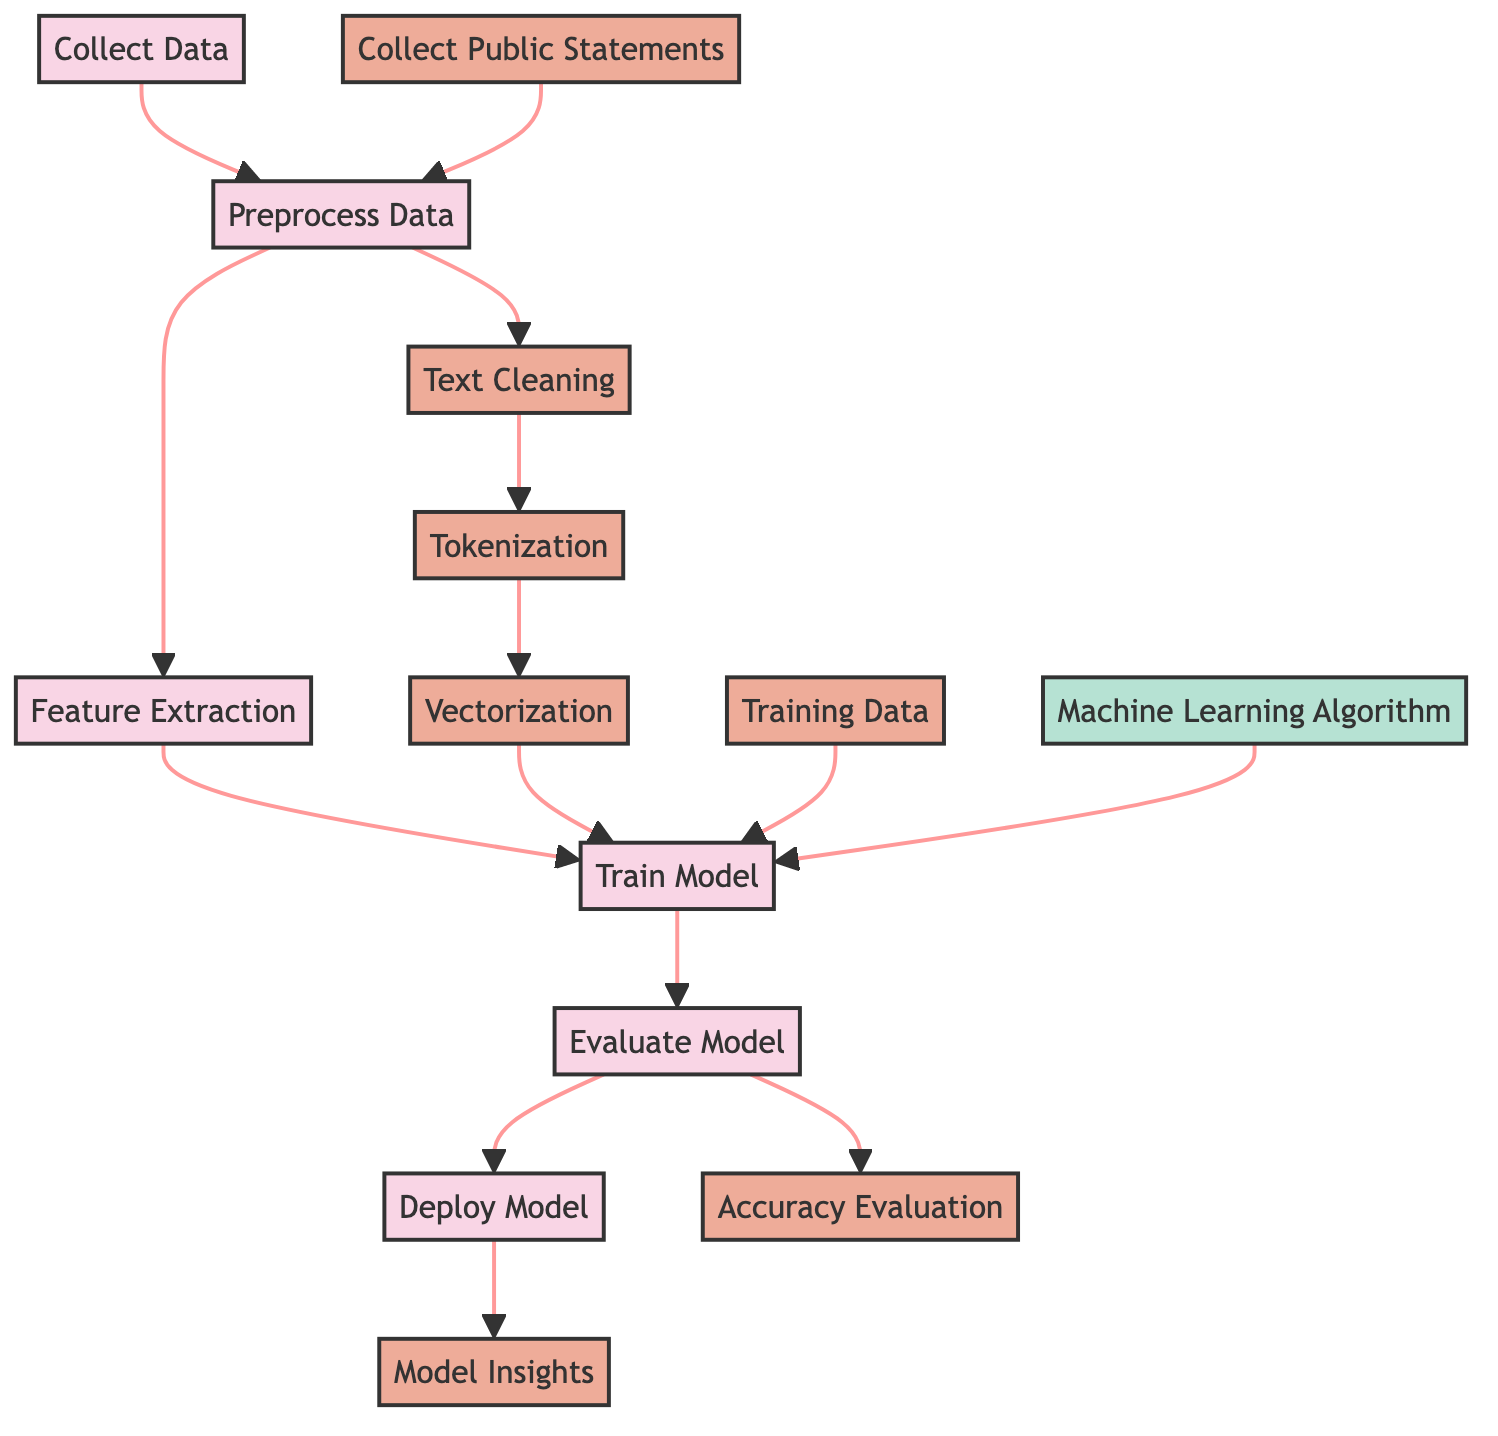What is the first process step in the diagram? The diagram starts with the node labeled "Collect Data," which indicates the first step in the text classification process for religious speech.
Answer: Collect Data How many nodes are there in the process section? There are five nodes categorized under the process section: Collect Data, Preprocess Data, Feature Extraction, Train Model, and Evaluate Model.
Answer: Five What type of data operation is performed after "Text Cleaning"? The diagram indicates that "Tokenization" is the operation that follows "Text Cleaning," signifying the breakdown of text into smaller units.
Answer: Tokenization What is the relationship between "Evaluate Model" and "Model Insights"? The "Evaluate Model" step leads to the "Model Insights" step, which indicates that after evaluation, insights from the model are gathered to understand its performance and implications.
Answer: It leads to Which step involves obtaining public statements? The step labeled "Collect Public Statements" is where public statements are obtained as part of the data collection process for the classification project.
Answer: Collect Public Statements How does "Feature Extraction" relate to "Train Model"? After completing "Feature Extraction," the output, which consists of extracted features, is used as input for the "Train Model" step to create a predictive model for classification.
Answer: It feeds into What are the three data-related nodes in the diagram? The three data-related nodes are "Collect Public Statements," "Text Cleaning," and "Vectorization," which are crucial for preparing data before it is utilized in the model training phase.
Answer: Three What is the final output of the process? The final output of the process as indicated in the diagram is "Model Insights," representing the conclusions and knowledge derived from the trained model's performance.
Answer: Model Insights What is the order of operation from data collection to model deployment? The operations conducted are: 1. Collect Data → 2. Preprocess Data → 3. Feature Extraction → 4. Train Model → 5. Evaluate Model → 6. Deploy Model, outlining the sequence of steps in the diagram.
Answer: Collect Data, Preprocess Data, Feature Extraction, Train Model, Evaluate Model, Deploy Model 